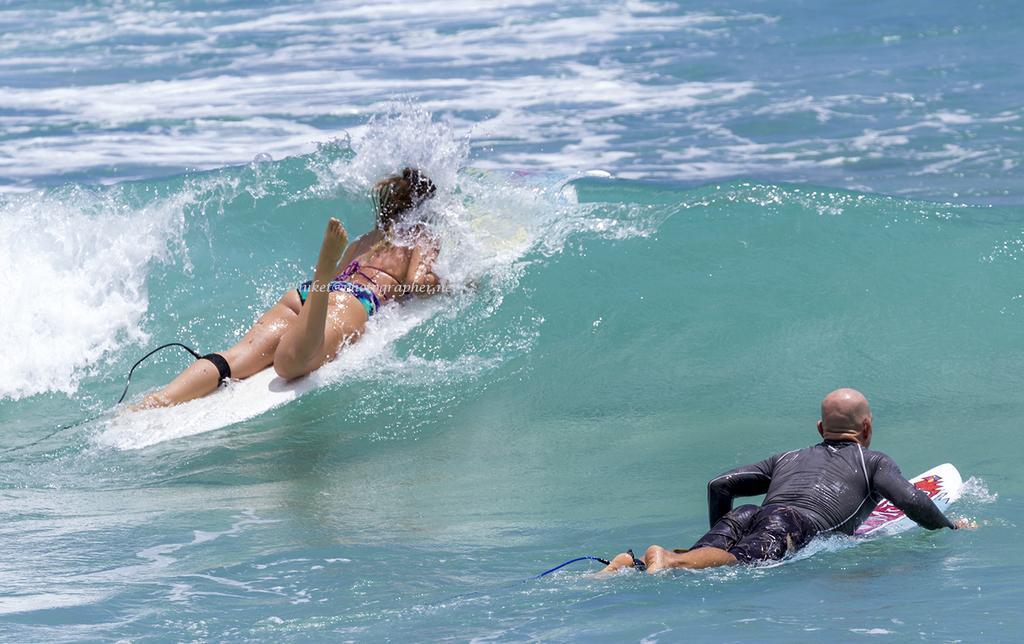Please provide a concise description of this image. In the image there is water and the two people are sliding on the surfing board. 